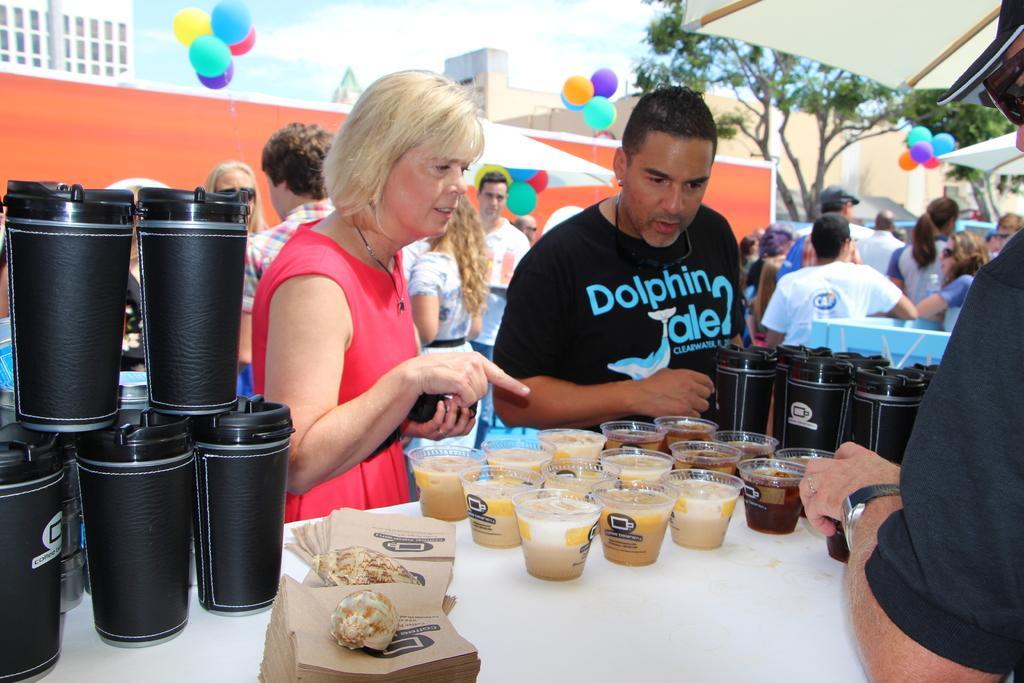How would you summarize this image in a sentence or two? In this image we can see people standing on the ground and tables are placed in front of them. On the tables there are disposal bottles, desserts in the disposal bowls, paper napkins, shells and tablecloths. In the background there are trees, sky, buildings and balloons. 